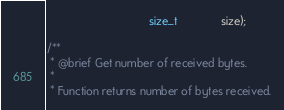Convert code to text. <code><loc_0><loc_0><loc_500><loc_500><_C_>                                size_t              size);

/**
 * @brief Get number of received bytes.
 *
 * Function returns number of bytes received.</code> 